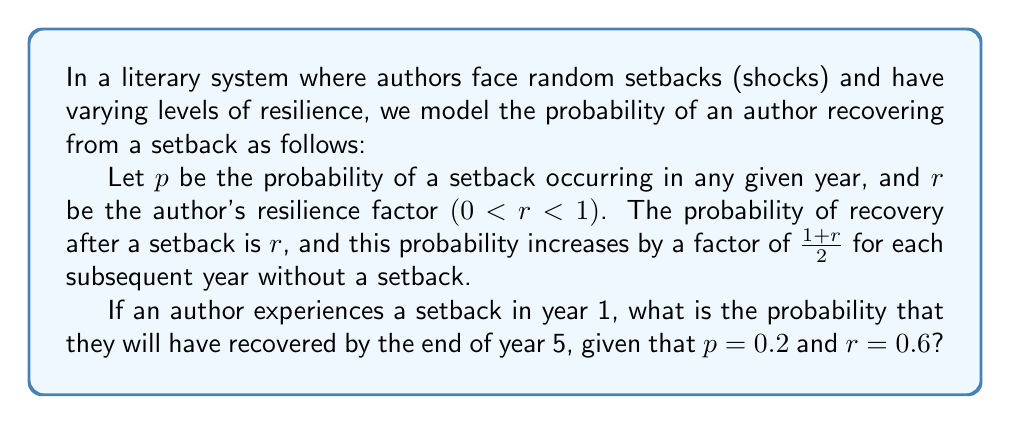Solve this math problem. Let's approach this step-by-step:

1) First, we need to calculate the probability of recovery for each year, assuming no new setbacks occur:

   Year 1: $r = 0.6$
   Year 2: $r \cdot \frac{1+r}{2} = 0.6 \cdot \frac{1.6}{2} = 0.48$
   Year 3: $0.48 \cdot \frac{1+r}{2} = 0.48 \cdot 0.8 = 0.384$
   Year 4: $0.384 \cdot 0.8 = 0.3072$
   Year 5: $0.3072 \cdot 0.8 = 0.24576$

2) Now, we need to calculate the probability of not having a setback for 0, 1, 2, 3, or 4 years after the initial setback:

   0 years: $(1-p)^0 = 1$
   1 year: $(1-p)^1 = 0.8$
   2 years: $(1-p)^2 = 0.64$
   3 years: $(1-p)^3 = 0.512$
   4 years: $(1-p)^4 = 0.4096$

3) The probability of recovery by the end of year 5 is the sum of:
   - Recovering in year 1: $0.6 \cdot 1 = 0.6$
   - Not recovering in year 1, but recovering in year 2: $(1-0.6) \cdot 0.48 \cdot 0.8 = 0.1536$
   - Not recovering in years 1-2, but recovering in year 3: $(1-0.6) \cdot (1-0.48) \cdot 0.384 \cdot 0.64 = 0.0516$
   - Not recovering in years 1-3, but recovering in year 4: $(1-0.6) \cdot (1-0.48) \cdot (1-0.384) \cdot 0.3072 \cdot 0.512 = 0.0158$
   - Not recovering in years 1-4, but recovering in year 5: $(1-0.6) \cdot (1-0.48) \cdot (1-0.384) \cdot (1-0.3072) \cdot 0.24576 \cdot 0.4096 = 0.0039$

4) Sum up all these probabilities:

   $0.6 + 0.1536 + 0.0516 + 0.0158 + 0.0039 = 0.8249$

Therefore, the probability of recovery by the end of year 5 is approximately 0.8249 or 82.49%.
Answer: $0.8249$ or $82.49\%$ 